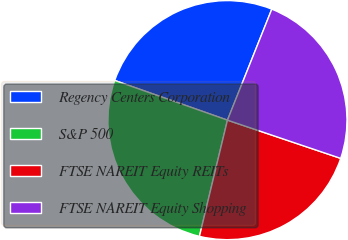<chart> <loc_0><loc_0><loc_500><loc_500><pie_chart><fcel>Regency Centers Corporation<fcel>S&P 500<fcel>FTSE NAREIT Equity REITs<fcel>FTSE NAREIT Equity Shopping<nl><fcel>25.66%<fcel>26.62%<fcel>23.58%<fcel>24.13%<nl></chart> 